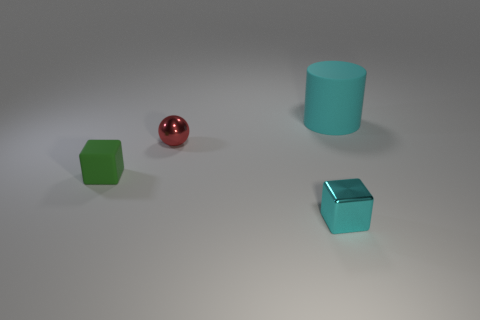What textures are visible in the image? Three distinct textures are present. The red ball has a smooth, reflective surface, while the green cube and cylinder have a matte finish. Lastly, the blue cube has a similar reflective surface to the red ball, indicating a polished texture. 